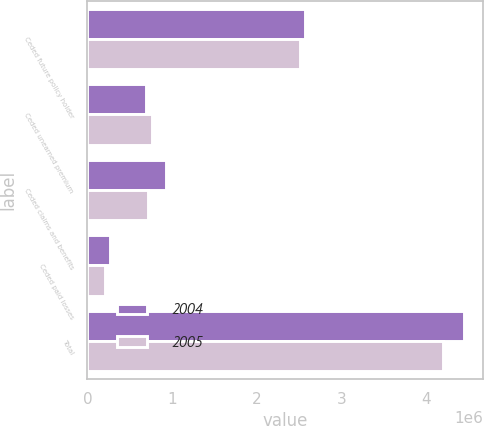<chart> <loc_0><loc_0><loc_500><loc_500><stacked_bar_chart><ecel><fcel>Ceded future policy holder<fcel>Ceded unearned premium<fcel>Ceded claims and benefits<fcel>Ceded paid losses<fcel>Total<nl><fcel>2004<fcel>2.56522e+06<fcel>691787<fcel>928882<fcel>261918<fcel>4.44781e+06<nl><fcel>2005<fcel>2.50745e+06<fcel>767124<fcel>716871<fcel>205365<fcel>4.19681e+06<nl></chart> 